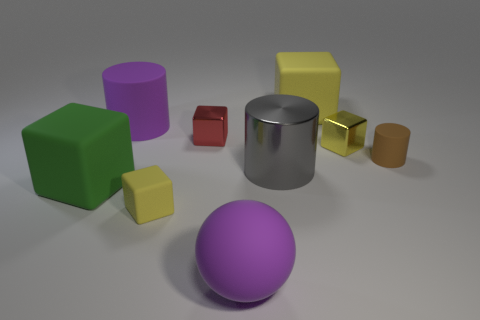Subtract all yellow blocks. How many were subtracted if there are1yellow blocks left? 2 Subtract all red balls. How many yellow blocks are left? 3 Subtract all green blocks. How many blocks are left? 4 Subtract all green matte blocks. How many blocks are left? 4 Subtract all gray cubes. Subtract all blue spheres. How many cubes are left? 5 Subtract all balls. How many objects are left? 8 Subtract all large purple cylinders. Subtract all metallic things. How many objects are left? 5 Add 7 small yellow objects. How many small yellow objects are left? 9 Add 3 big rubber things. How many big rubber things exist? 7 Subtract 0 yellow cylinders. How many objects are left? 9 